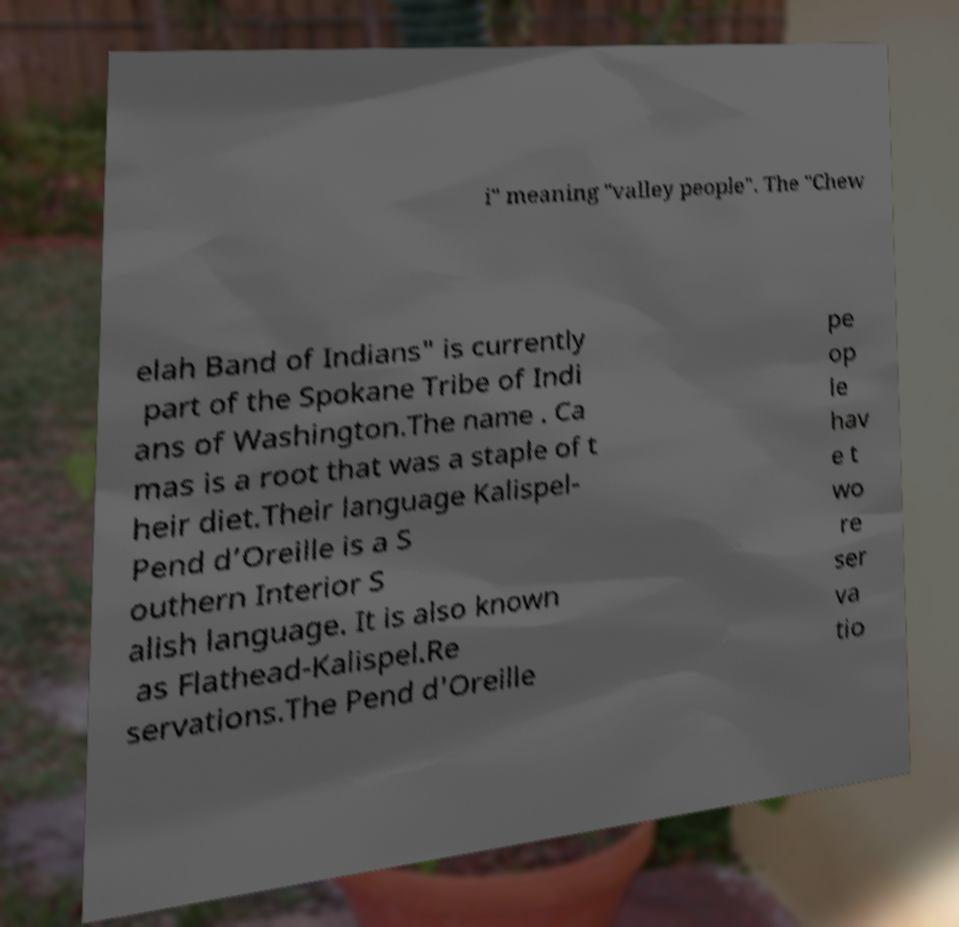Can you read and provide the text displayed in the image?This photo seems to have some interesting text. Can you extract and type it out for me? i" meaning "valley people". The "Chew elah Band of Indians" is currently part of the Spokane Tribe of Indi ans of Washington.The name . Ca mas is a root that was a staple of t heir diet.Their language Kalispel- Pend d’Oreille is a S outhern Interior S alish language. It is also known as Flathead-Kalispel.Re servations.The Pend d'Oreille pe op le hav e t wo re ser va tio 